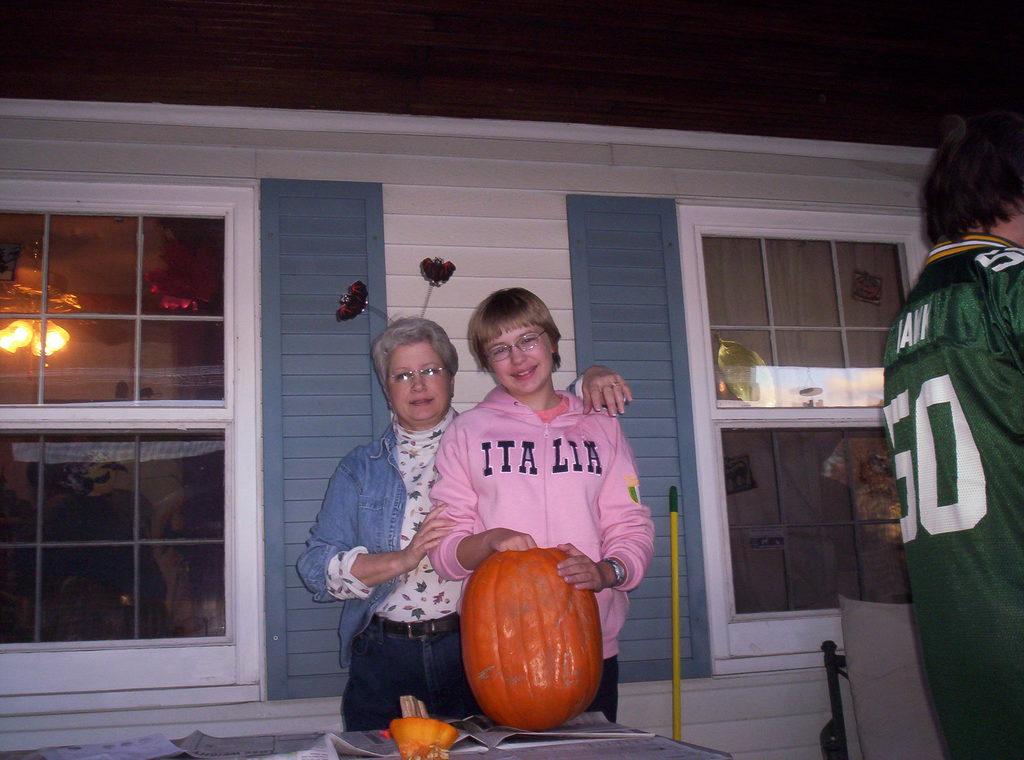What number is on the green jersey?
Ensure brevity in your answer.  50. 